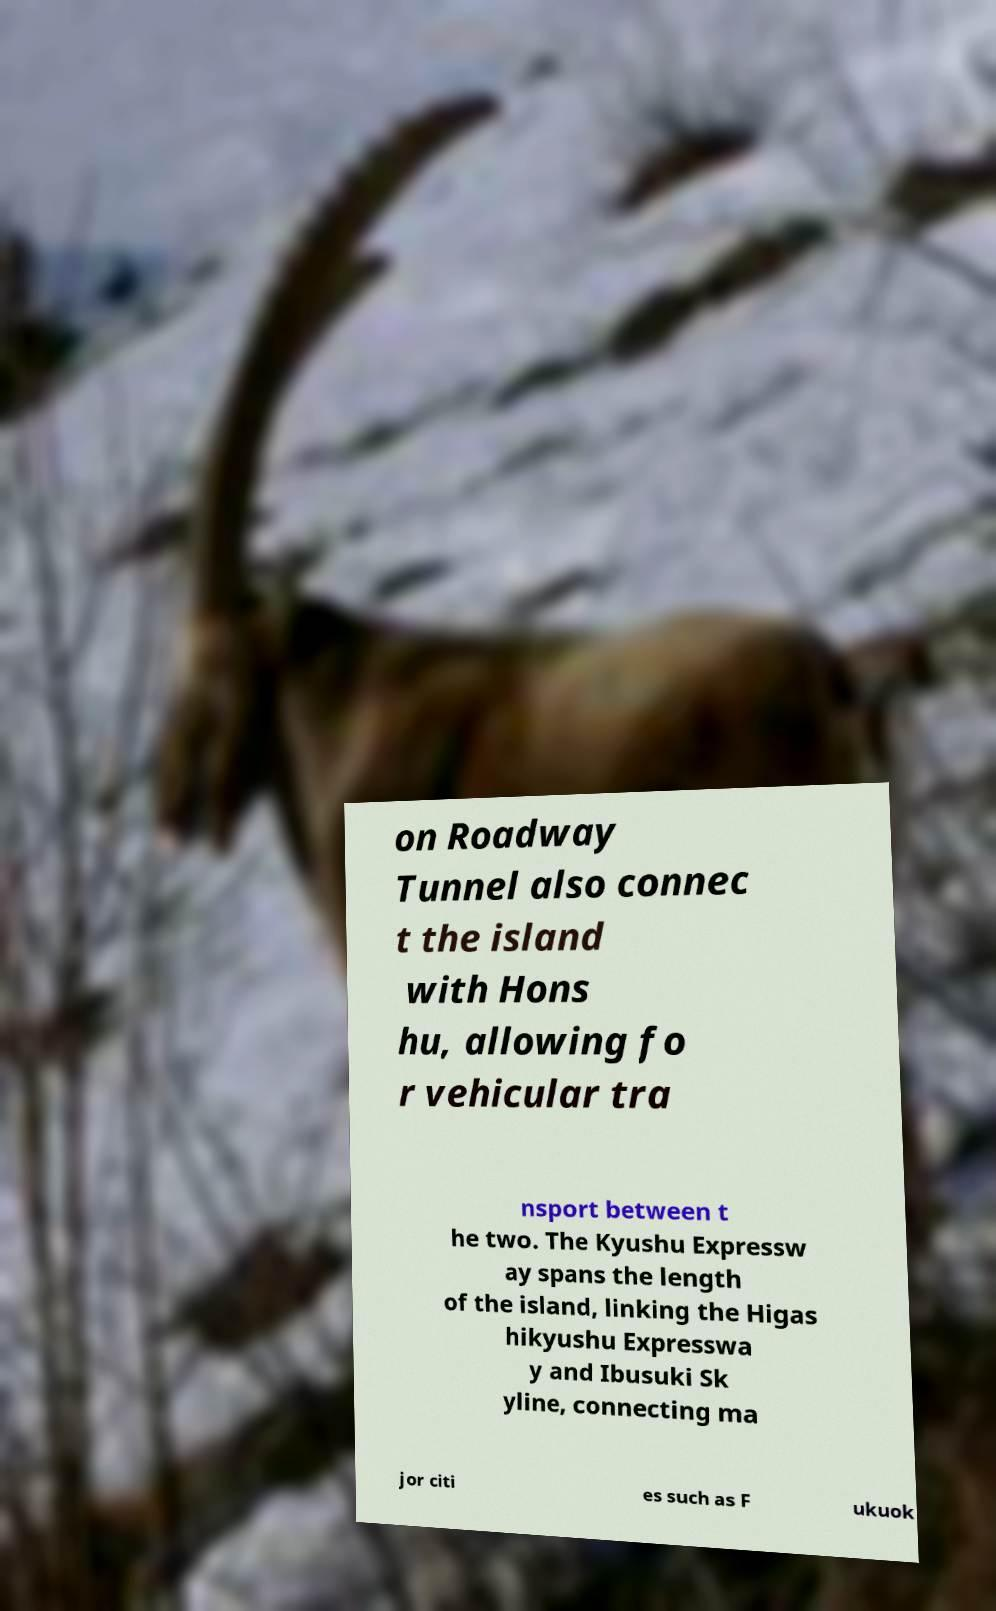What messages or text are displayed in this image? I need them in a readable, typed format. on Roadway Tunnel also connec t the island with Hons hu, allowing fo r vehicular tra nsport between t he two. The Kyushu Expressw ay spans the length of the island, linking the Higas hikyushu Expresswa y and Ibusuki Sk yline, connecting ma jor citi es such as F ukuok 